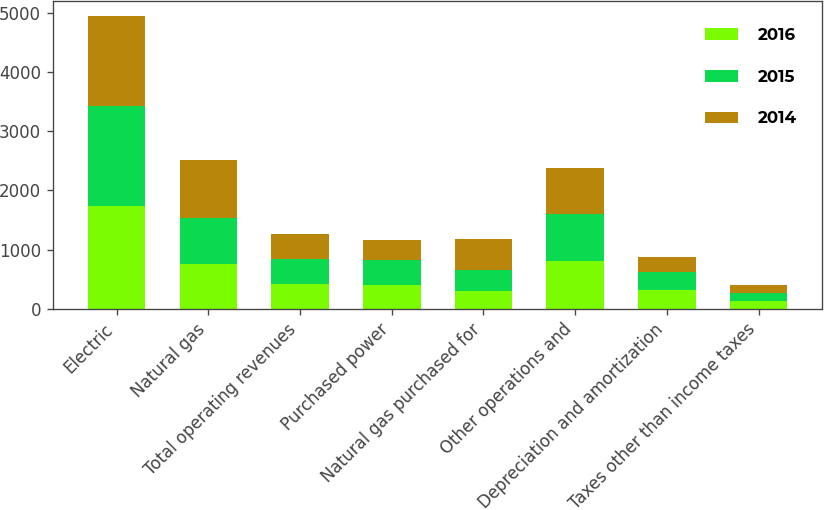Convert chart. <chart><loc_0><loc_0><loc_500><loc_500><stacked_bar_chart><ecel><fcel>Electric<fcel>Natural gas<fcel>Total operating revenues<fcel>Purchased power<fcel>Natural gas purchased for<fcel>Other operations and<fcel>Depreciation and amortization<fcel>Taxes other than income taxes<nl><fcel>2016<fcel>1736<fcel>754<fcel>420<fcel>399<fcel>292<fcel>804<fcel>319<fcel>132<nl><fcel>2015<fcel>1683<fcel>783<fcel>420<fcel>420<fcel>358<fcel>797<fcel>295<fcel>130<nl><fcel>2014<fcel>1522<fcel>976<fcel>420<fcel>343<fcel>533<fcel>771<fcel>263<fcel>138<nl></chart> 